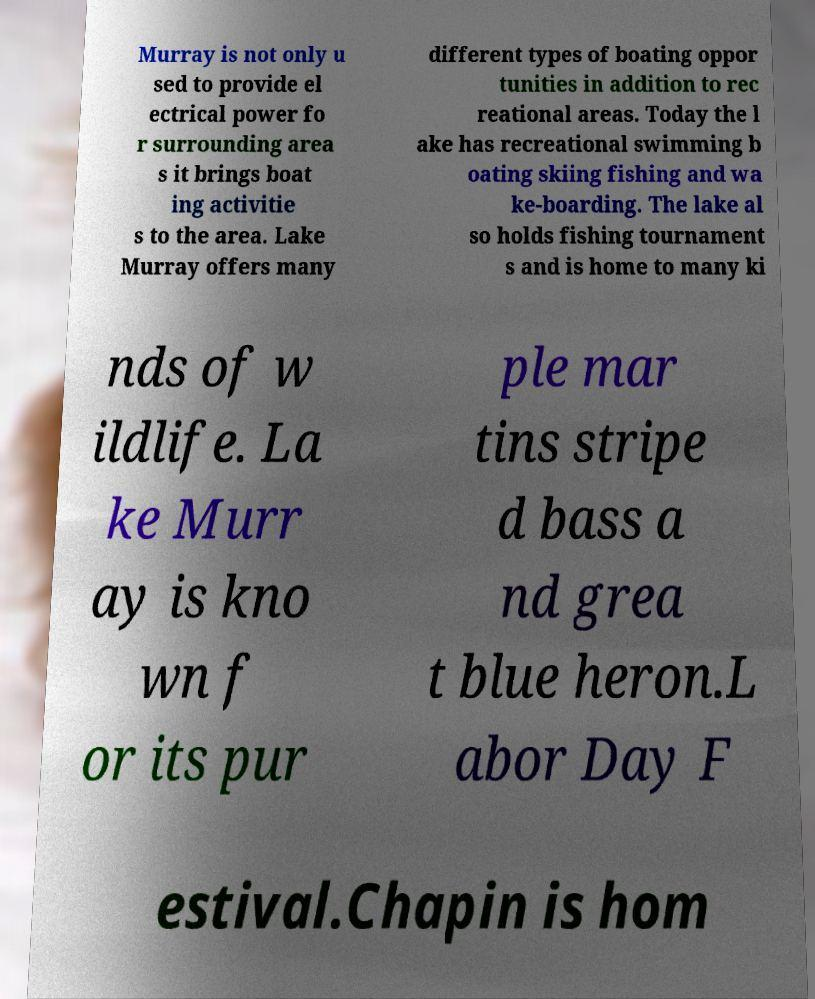Please identify and transcribe the text found in this image. Murray is not only u sed to provide el ectrical power fo r surrounding area s it brings boat ing activitie s to the area. Lake Murray offers many different types of boating oppor tunities in addition to rec reational areas. Today the l ake has recreational swimming b oating skiing fishing and wa ke-boarding. The lake al so holds fishing tournament s and is home to many ki nds of w ildlife. La ke Murr ay is kno wn f or its pur ple mar tins stripe d bass a nd grea t blue heron.L abor Day F estival.Chapin is hom 